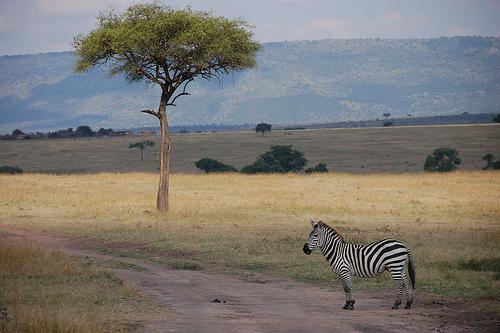Question: what is the animal?
Choices:
A. An elephant.
B. A cow.
C. A horse.
D. A zebra.
Answer with the letter. Answer: D Question: who is in the picture?
Choices:
A. A horse.
B. An animal.
C. A pig.
D. A chicken.
Answer with the letter. Answer: B Question: what does a zebra have?
Choices:
A. Grass.
B. Fur.
C. Food.
D. Stripes.
Answer with the letter. Answer: D 